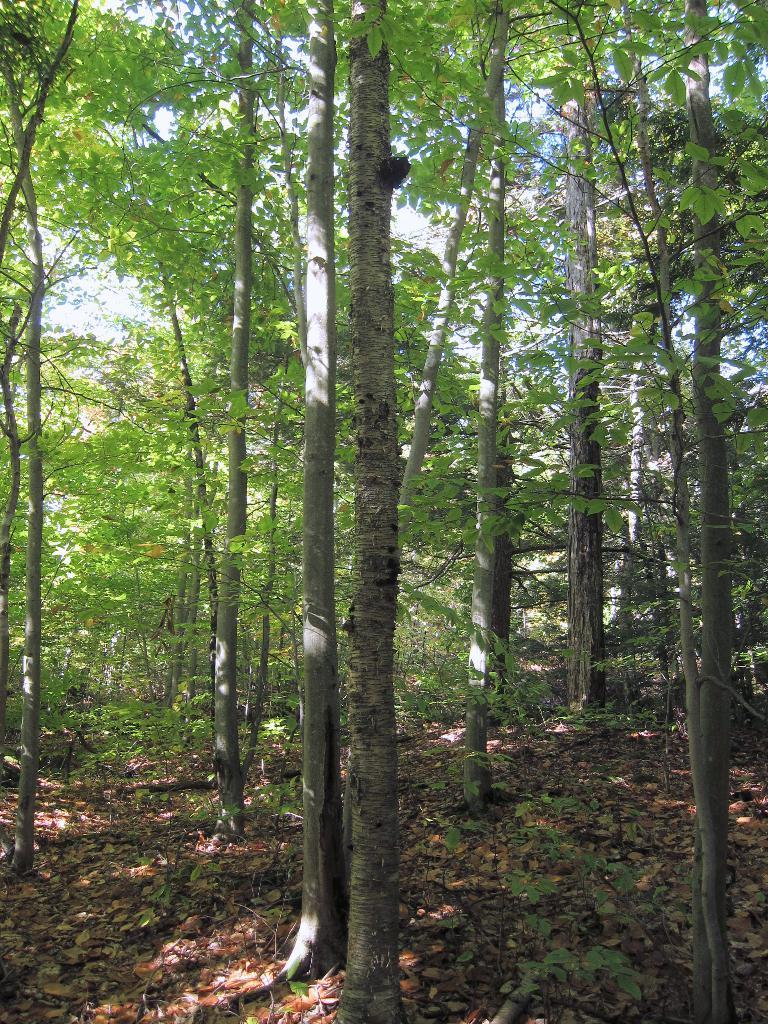What type of surface can be seen in the image? There is ground visible in the image. What is present on the ground? There are dried leaves and plants on the ground. What type of vegetation is present in the image? There are trees in the image. What is visible above the ground and trees? The sky is visible in the image. What type of bun is being used as a hat by the snake in the image? There is no bun or snake present in the image. 